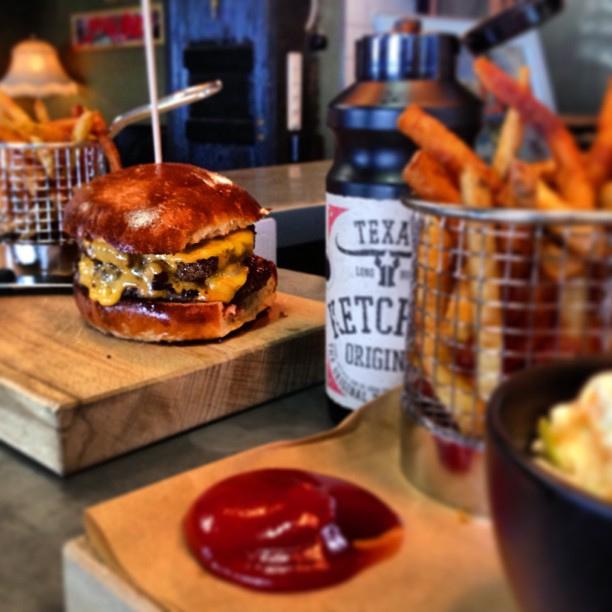Did this food come from Taco Bell?
Short answer required. No. How does one make French fries?
Give a very brief answer. Fry. What condiment is being used?
Short answer required. Ketchup. 